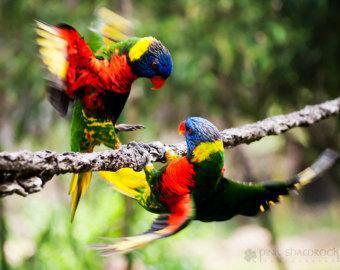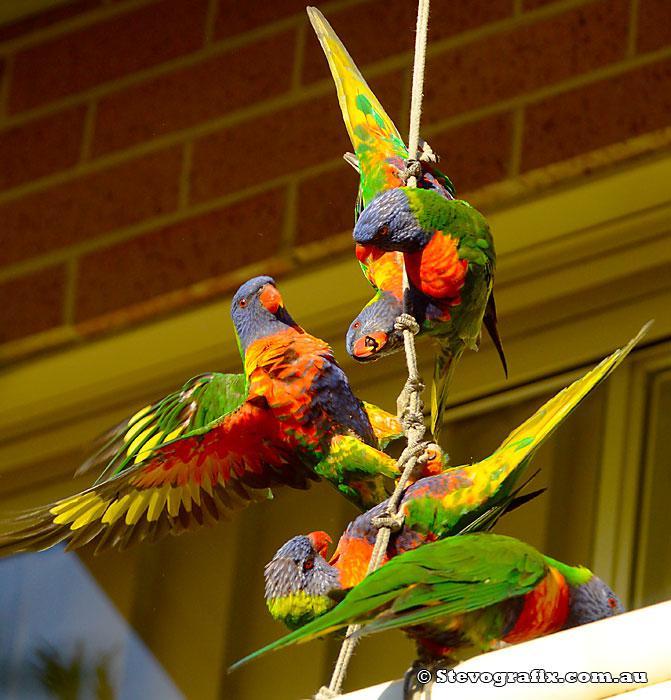The first image is the image on the left, the second image is the image on the right. Evaluate the accuracy of this statement regarding the images: "There are no more than two parrots in the right image.". Is it true? Answer yes or no. No. The first image is the image on the left, the second image is the image on the right. Given the left and right images, does the statement "There are no less than five colorful birds" hold true? Answer yes or no. Yes. 